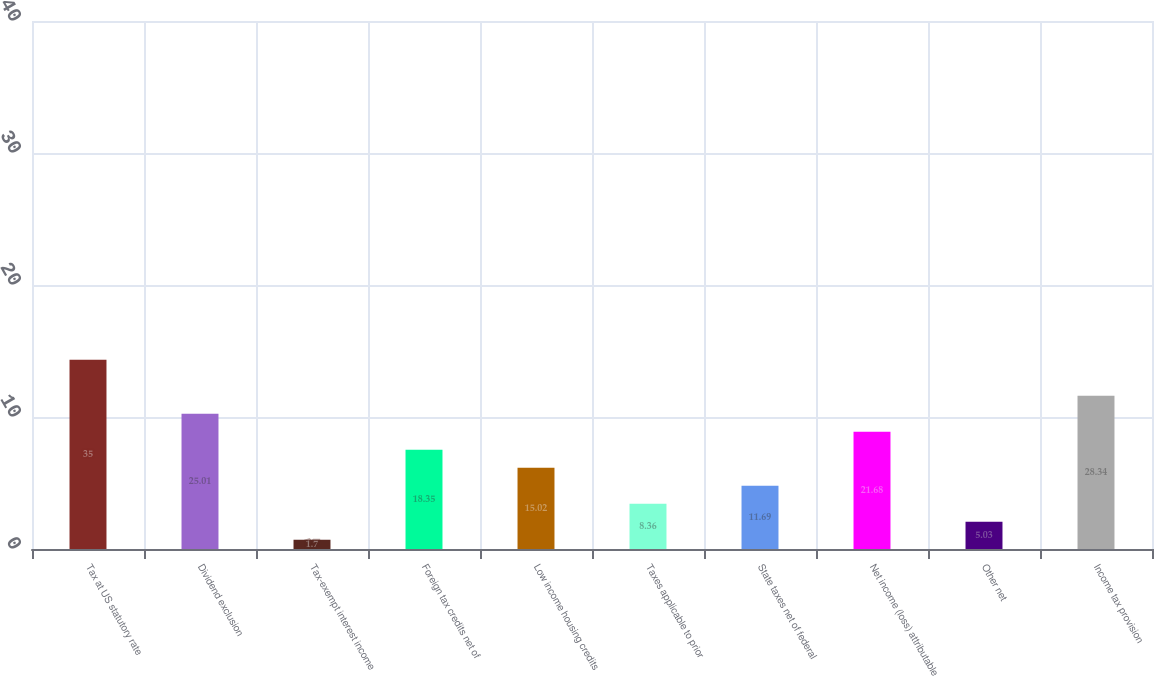Convert chart. <chart><loc_0><loc_0><loc_500><loc_500><bar_chart><fcel>Tax at US statutory rate<fcel>Dividend exclusion<fcel>Tax-exempt interest income<fcel>Foreign tax credits net of<fcel>Low income housing credits<fcel>Taxes applicable to prior<fcel>State taxes net of federal<fcel>Net income (loss) attributable<fcel>Other net<fcel>Income tax provision<nl><fcel>35<fcel>25.01<fcel>1.7<fcel>18.35<fcel>15.02<fcel>8.36<fcel>11.69<fcel>21.68<fcel>5.03<fcel>28.34<nl></chart> 